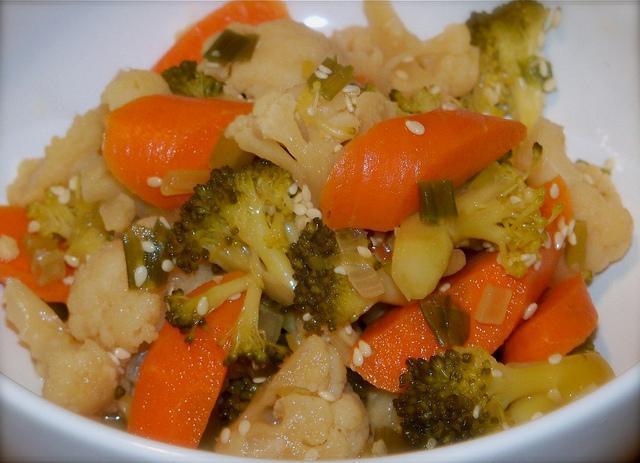How many kinds of vegetables are there?
Give a very brief answer. 3. How many carrots can you see?
Give a very brief answer. 7. How many broccolis are there?
Give a very brief answer. 6. 